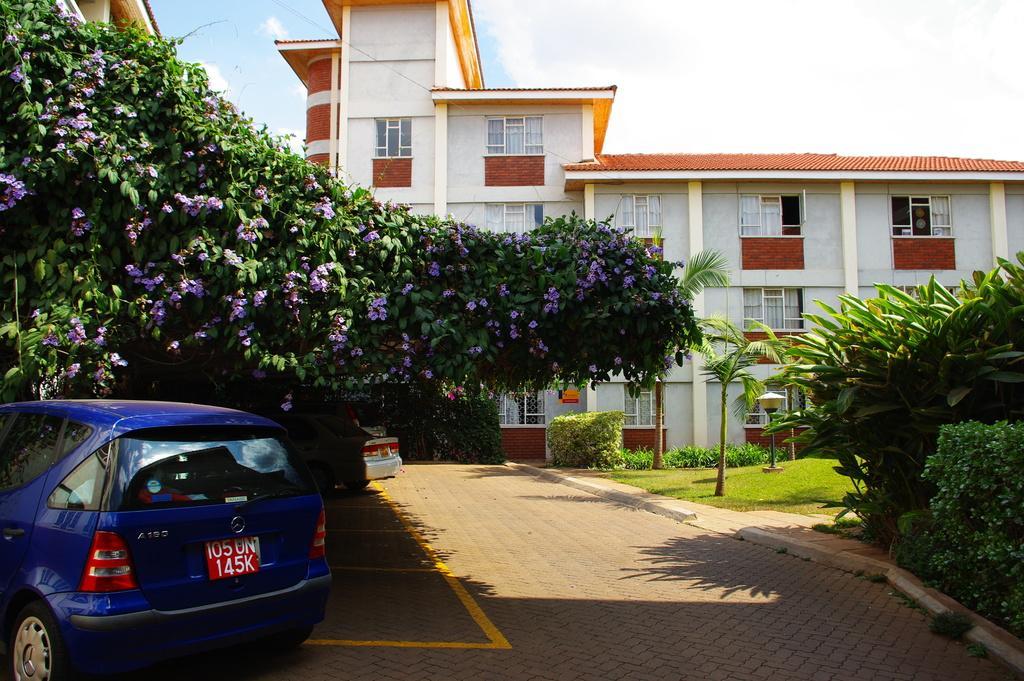How would you summarize this image in a sentence or two? In this picture we can see few cars, plants and flowers, in the background we can see few buildings, trees and clouds. 